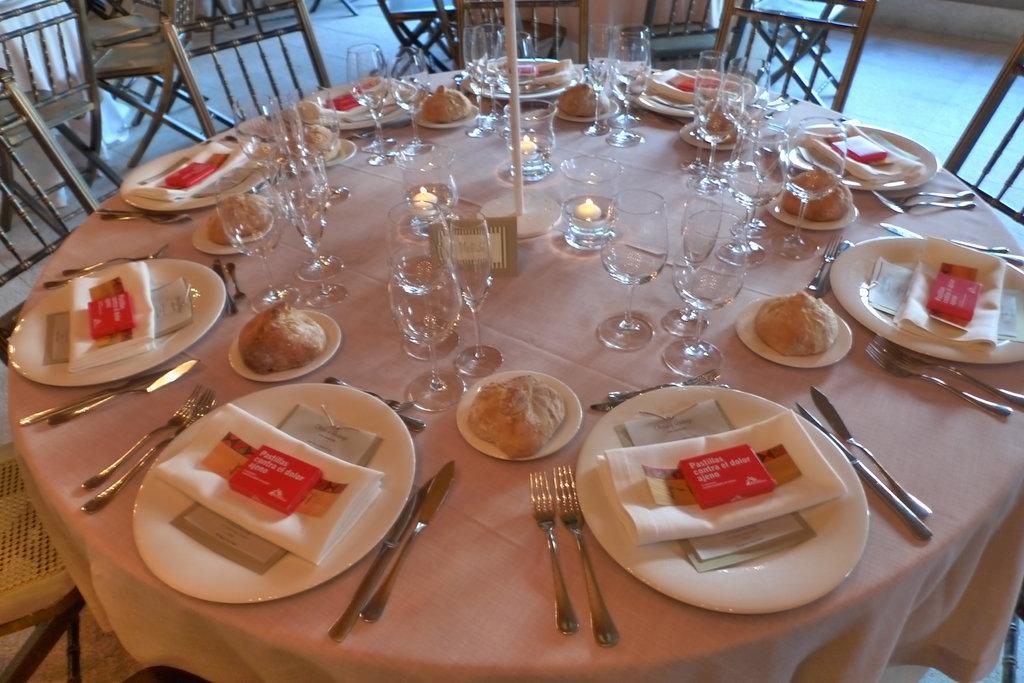Could you give a brief overview of what you see in this image? In this image I can see plates,tissues,forks,spoons,glasses,food items,board on the table. Peach color cloth is covered on the table. I can see few chairs. 